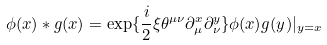Convert formula to latex. <formula><loc_0><loc_0><loc_500><loc_500>\phi ( x ) * g ( x ) = \exp \{ \frac { i } { 2 } \xi \theta ^ { \mu \nu } \partial _ { \mu } ^ { x } \partial _ { \nu } ^ { y } \} \phi ( x ) g ( y ) | _ { y = x }</formula> 